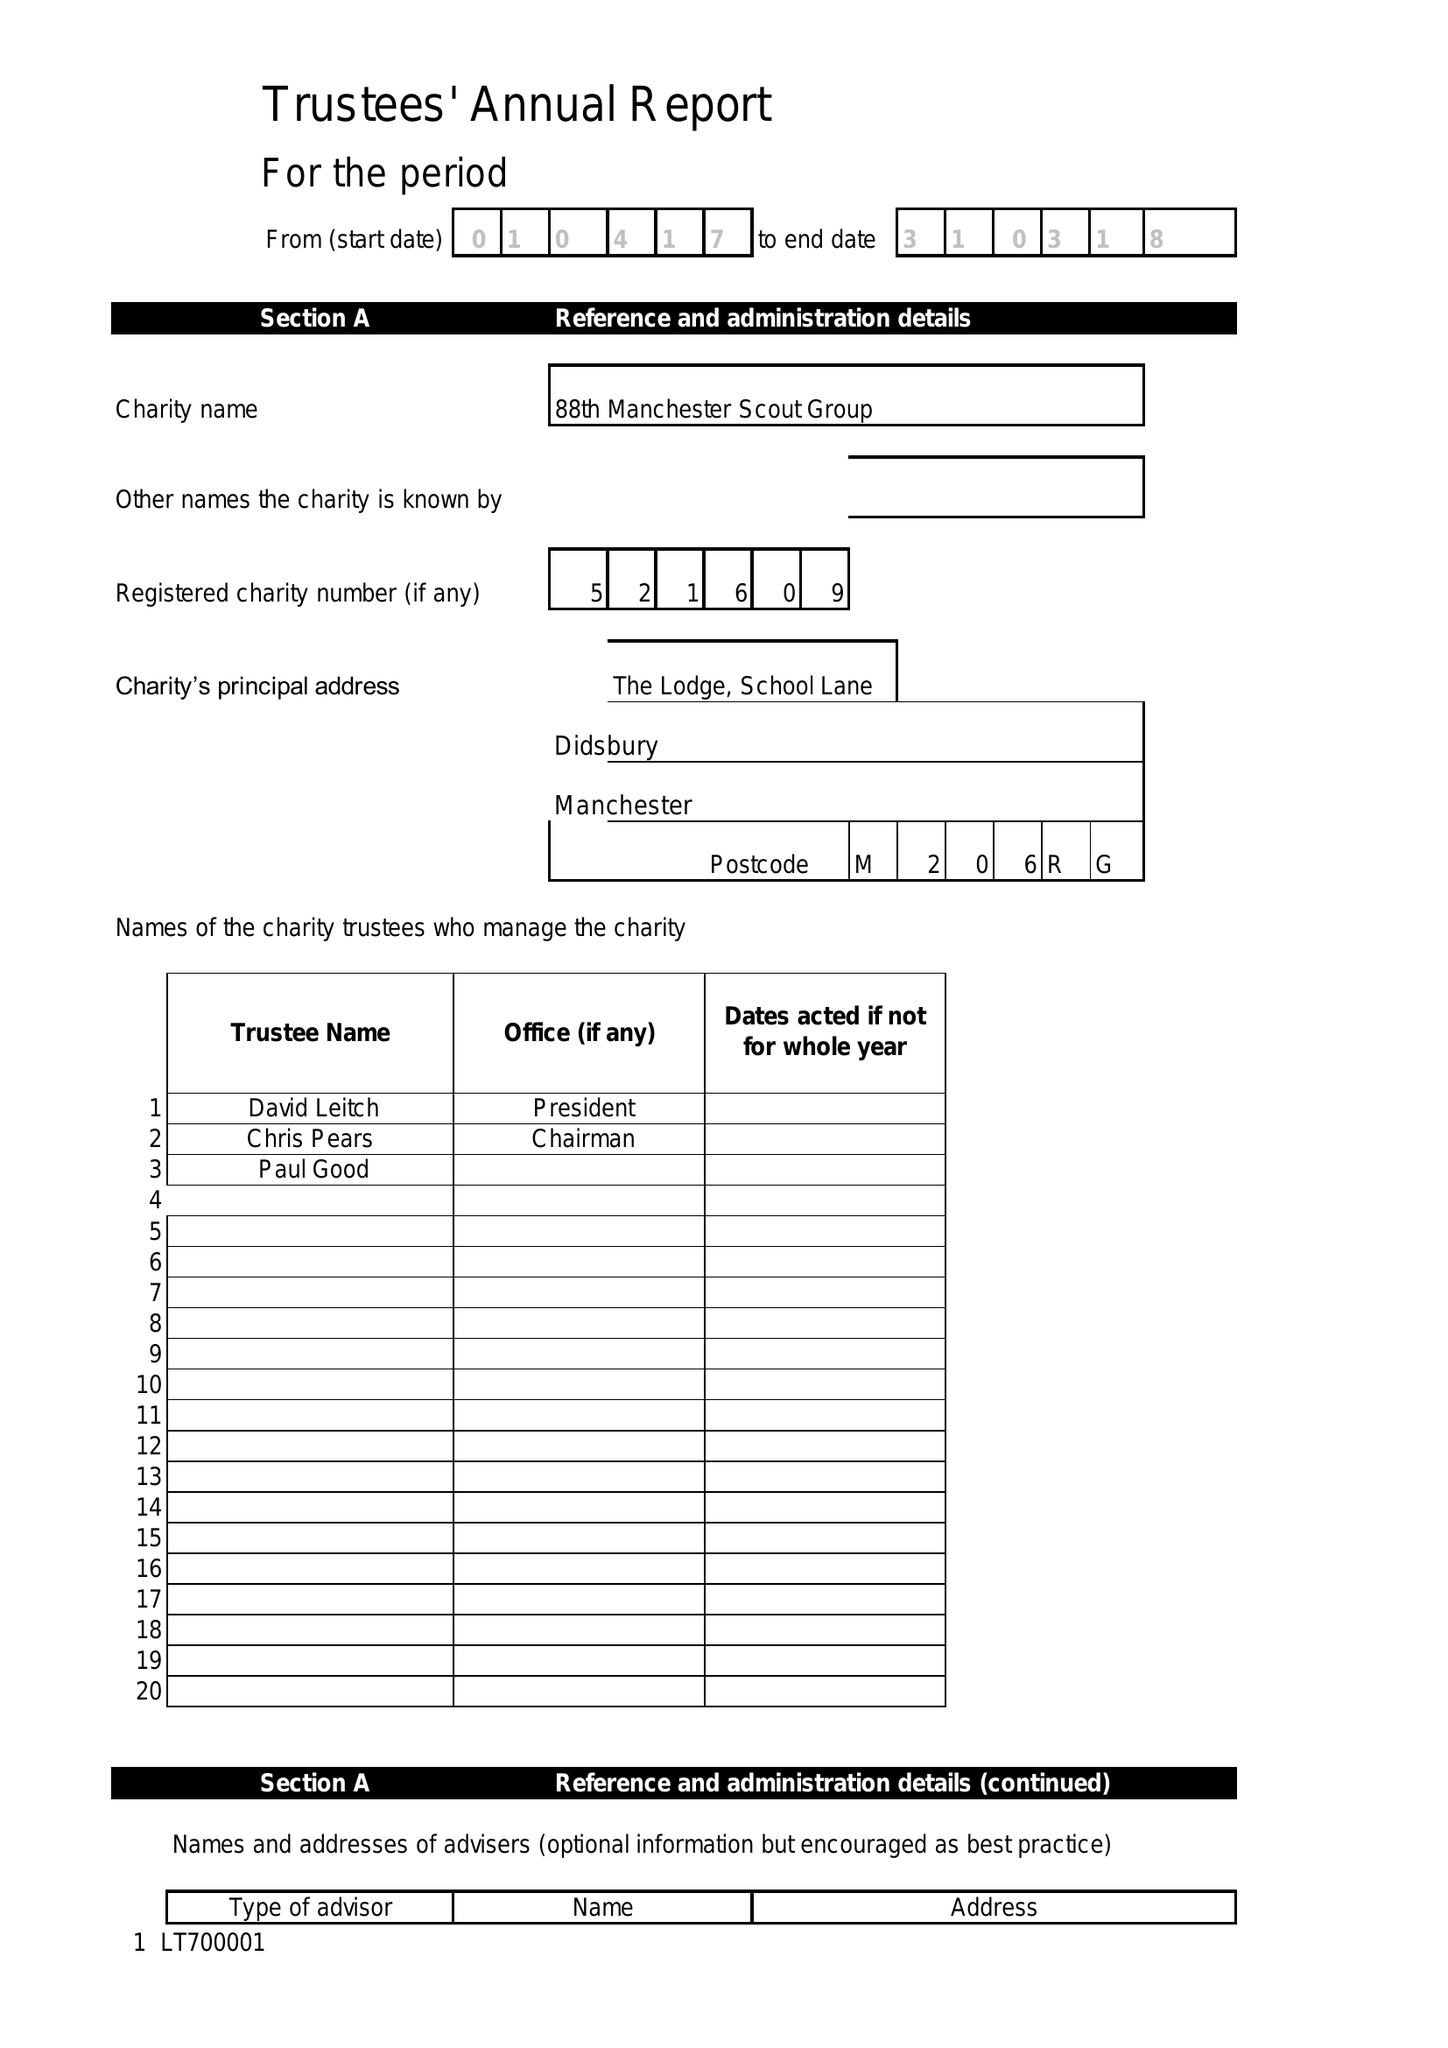What is the value for the income_annually_in_british_pounds?
Answer the question using a single word or phrase. 29101.00 